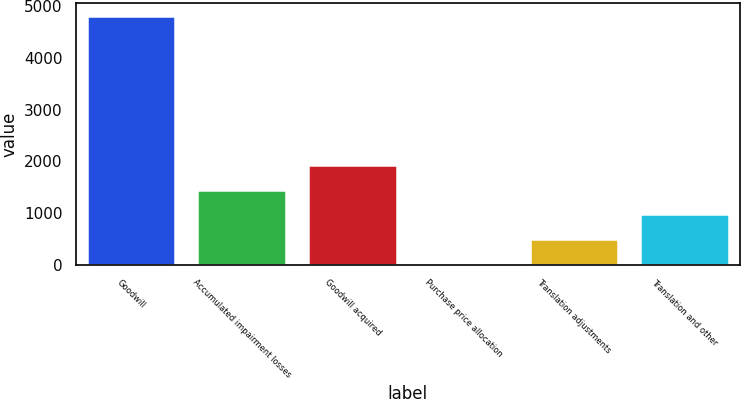<chart> <loc_0><loc_0><loc_500><loc_500><bar_chart><fcel>Goodwill<fcel>Accumulated impairment losses<fcel>Goodwill acquired<fcel>Purchase price allocation<fcel>Translation adjustments<fcel>Translation and other<nl><fcel>4820.9<fcel>1451.94<fcel>1933.22<fcel>8.1<fcel>489.38<fcel>970.66<nl></chart> 